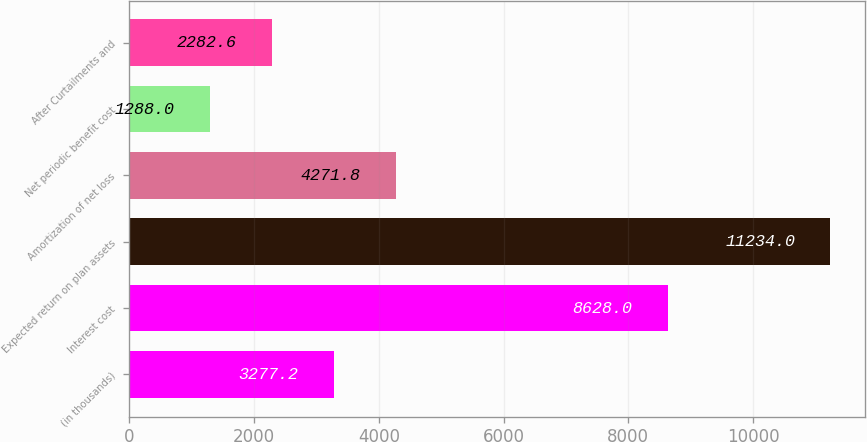<chart> <loc_0><loc_0><loc_500><loc_500><bar_chart><fcel>(in thousands)<fcel>Interest cost<fcel>Expected return on plan assets<fcel>Amortization of net loss<fcel>Net periodic benefit cost<fcel>After Curtailments and<nl><fcel>3277.2<fcel>8628<fcel>11234<fcel>4271.8<fcel>1288<fcel>2282.6<nl></chart> 